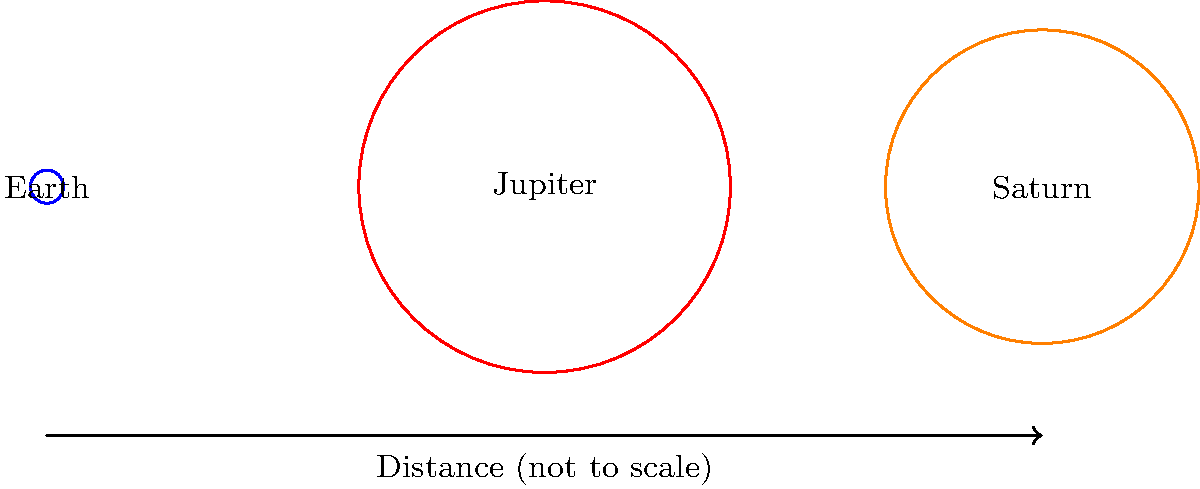In your latest indie rock album, you've decided to include a song about the solar system. While researching, you come across this diagram showing the relative sizes of Earth, Jupiter, and Saturn. If Earth's radius is used as the unit of measurement, approximately how many times larger is Jupiter's radius compared to Saturn's? To solve this problem, let's follow these steps:

1. Identify the given information:
   - Earth's radius is the unit of measurement (1 unit)
   - Jupiter's radius is 11.2 units
   - Saturn's radius is 9.45 units

2. To compare Jupiter's radius to Saturn's, we need to divide Jupiter's radius by Saturn's radius:

   $\frac{\text{Jupiter's radius}}{\text{Saturn's radius}} = \frac{11.2}{9.45}$

3. Perform the division:
   
   $\frac{11.2}{9.45} \approx 1.185$

4. Interpret the result:
   Jupiter's radius is approximately 1.185 times larger than Saturn's radius.

5. To express this as a percentage difference:
   $(1.185 - 1) \times 100\% \approx 18.5\%$

Therefore, Jupiter's radius is about 18.5% larger than Saturn's radius.
Answer: 1.185 times or 18.5% larger 